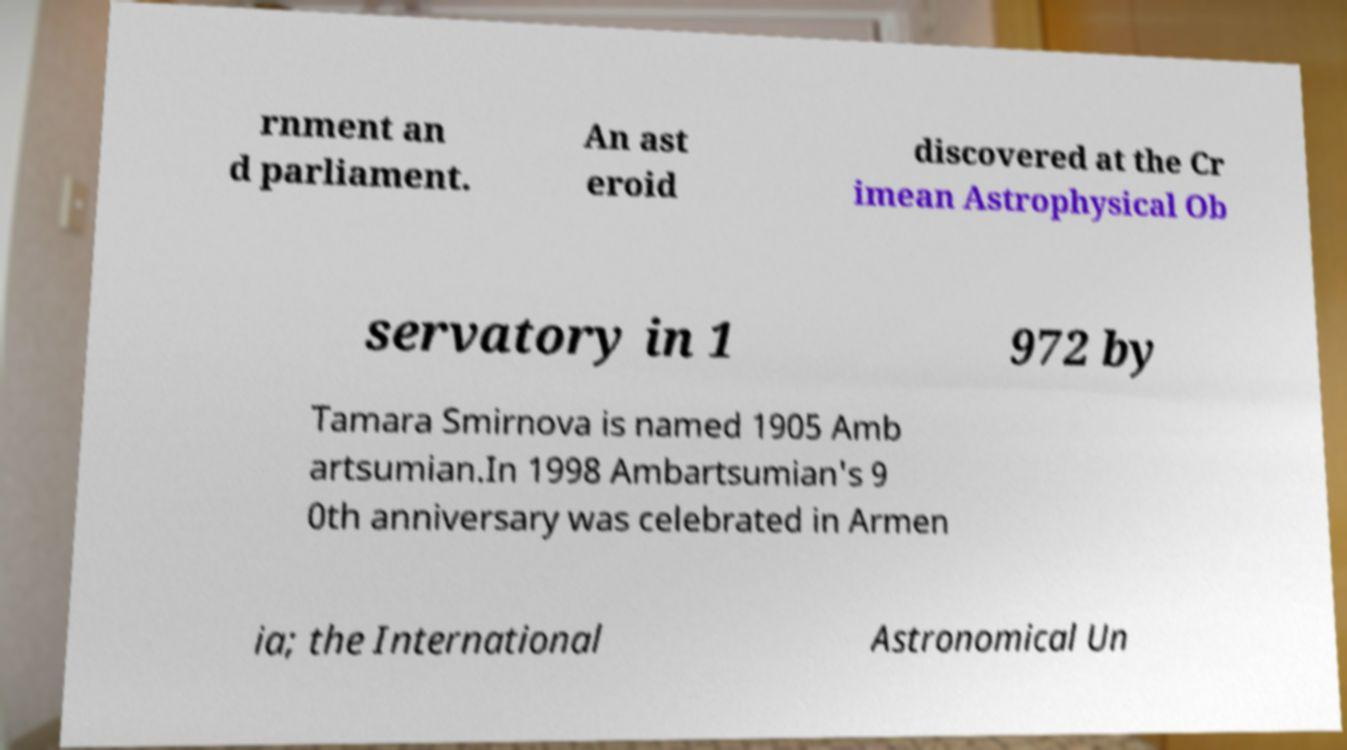Could you extract and type out the text from this image? rnment an d parliament. An ast eroid discovered at the Cr imean Astrophysical Ob servatory in 1 972 by Tamara Smirnova is named 1905 Amb artsumian.In 1998 Ambartsumian's 9 0th anniversary was celebrated in Armen ia; the International Astronomical Un 